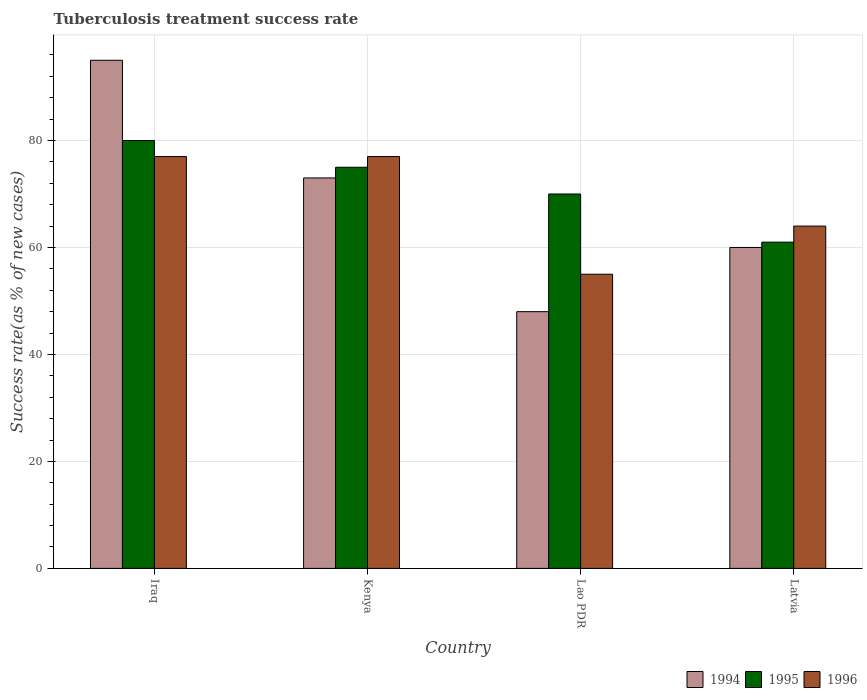How many different coloured bars are there?
Offer a terse response. 3. How many groups of bars are there?
Offer a very short reply. 4. Are the number of bars per tick equal to the number of legend labels?
Ensure brevity in your answer.  Yes. How many bars are there on the 1st tick from the left?
Offer a very short reply. 3. How many bars are there on the 1st tick from the right?
Your answer should be very brief. 3. What is the label of the 4th group of bars from the left?
Ensure brevity in your answer.  Latvia. In which country was the tuberculosis treatment success rate in 1994 maximum?
Your answer should be compact. Iraq. In which country was the tuberculosis treatment success rate in 1995 minimum?
Your answer should be compact. Latvia. What is the total tuberculosis treatment success rate in 1995 in the graph?
Ensure brevity in your answer.  286. What is the difference between the tuberculosis treatment success rate in 1994 in Kenya and the tuberculosis treatment success rate in 1996 in Lao PDR?
Your response must be concise. 18. What is the average tuberculosis treatment success rate in 1995 per country?
Keep it short and to the point. 71.5. What is the difference between the tuberculosis treatment success rate of/in 1994 and tuberculosis treatment success rate of/in 1996 in Latvia?
Make the answer very short. -4. In how many countries, is the tuberculosis treatment success rate in 1995 greater than 72 %?
Give a very brief answer. 2. What is the ratio of the tuberculosis treatment success rate in 1995 in Kenya to that in Latvia?
Your response must be concise. 1.23. What is the difference between the highest and the lowest tuberculosis treatment success rate in 1994?
Provide a short and direct response. 47. What does the 3rd bar from the left in Iraq represents?
Your answer should be compact. 1996. What does the 3rd bar from the right in Lao PDR represents?
Your answer should be very brief. 1994. How many bars are there?
Your answer should be very brief. 12. Are all the bars in the graph horizontal?
Give a very brief answer. No. What is the difference between two consecutive major ticks on the Y-axis?
Your answer should be very brief. 20. Does the graph contain any zero values?
Offer a terse response. No. Does the graph contain grids?
Your answer should be compact. Yes. How are the legend labels stacked?
Your response must be concise. Horizontal. What is the title of the graph?
Your answer should be very brief. Tuberculosis treatment success rate. Does "1968" appear as one of the legend labels in the graph?
Make the answer very short. No. What is the label or title of the X-axis?
Keep it short and to the point. Country. What is the label or title of the Y-axis?
Your answer should be very brief. Success rate(as % of new cases). What is the Success rate(as % of new cases) of 1994 in Iraq?
Your answer should be compact. 95. What is the Success rate(as % of new cases) in 1996 in Iraq?
Keep it short and to the point. 77. What is the Success rate(as % of new cases) in 1995 in Kenya?
Offer a terse response. 75. What is the Success rate(as % of new cases) of 1996 in Kenya?
Offer a terse response. 77. What is the Success rate(as % of new cases) in 1995 in Lao PDR?
Provide a succinct answer. 70. What is the Success rate(as % of new cases) of 1994 in Latvia?
Provide a succinct answer. 60. What is the Success rate(as % of new cases) in 1996 in Latvia?
Ensure brevity in your answer.  64. Across all countries, what is the maximum Success rate(as % of new cases) of 1994?
Give a very brief answer. 95. Across all countries, what is the maximum Success rate(as % of new cases) of 1995?
Provide a short and direct response. 80. Across all countries, what is the maximum Success rate(as % of new cases) of 1996?
Provide a short and direct response. 77. Across all countries, what is the minimum Success rate(as % of new cases) in 1994?
Your answer should be compact. 48. What is the total Success rate(as % of new cases) in 1994 in the graph?
Offer a terse response. 276. What is the total Success rate(as % of new cases) in 1995 in the graph?
Ensure brevity in your answer.  286. What is the total Success rate(as % of new cases) in 1996 in the graph?
Keep it short and to the point. 273. What is the difference between the Success rate(as % of new cases) in 1996 in Iraq and that in Kenya?
Offer a very short reply. 0. What is the difference between the Success rate(as % of new cases) in 1994 in Iraq and that in Lao PDR?
Provide a short and direct response. 47. What is the difference between the Success rate(as % of new cases) of 1995 in Iraq and that in Lao PDR?
Provide a short and direct response. 10. What is the difference between the Success rate(as % of new cases) of 1995 in Iraq and that in Latvia?
Your answer should be compact. 19. What is the difference between the Success rate(as % of new cases) of 1994 in Lao PDR and that in Latvia?
Your response must be concise. -12. What is the difference between the Success rate(as % of new cases) of 1996 in Lao PDR and that in Latvia?
Give a very brief answer. -9. What is the difference between the Success rate(as % of new cases) of 1994 in Iraq and the Success rate(as % of new cases) of 1996 in Kenya?
Make the answer very short. 18. What is the difference between the Success rate(as % of new cases) of 1995 in Iraq and the Success rate(as % of new cases) of 1996 in Lao PDR?
Make the answer very short. 25. What is the difference between the Success rate(as % of new cases) in 1994 in Iraq and the Success rate(as % of new cases) in 1995 in Latvia?
Make the answer very short. 34. What is the difference between the Success rate(as % of new cases) in 1994 in Iraq and the Success rate(as % of new cases) in 1996 in Latvia?
Your response must be concise. 31. What is the difference between the Success rate(as % of new cases) in 1995 in Iraq and the Success rate(as % of new cases) in 1996 in Latvia?
Keep it short and to the point. 16. What is the difference between the Success rate(as % of new cases) of 1994 in Kenya and the Success rate(as % of new cases) of 1996 in Lao PDR?
Give a very brief answer. 18. What is the difference between the Success rate(as % of new cases) in 1995 in Kenya and the Success rate(as % of new cases) in 1996 in Lao PDR?
Provide a short and direct response. 20. What is the difference between the Success rate(as % of new cases) in 1995 in Lao PDR and the Success rate(as % of new cases) in 1996 in Latvia?
Make the answer very short. 6. What is the average Success rate(as % of new cases) of 1994 per country?
Provide a succinct answer. 69. What is the average Success rate(as % of new cases) of 1995 per country?
Make the answer very short. 71.5. What is the average Success rate(as % of new cases) of 1996 per country?
Make the answer very short. 68.25. What is the difference between the Success rate(as % of new cases) in 1994 and Success rate(as % of new cases) in 1995 in Iraq?
Provide a succinct answer. 15. What is the difference between the Success rate(as % of new cases) in 1994 and Success rate(as % of new cases) in 1995 in Kenya?
Provide a succinct answer. -2. What is the difference between the Success rate(as % of new cases) of 1994 and Success rate(as % of new cases) of 1996 in Kenya?
Make the answer very short. -4. What is the difference between the Success rate(as % of new cases) in 1994 and Success rate(as % of new cases) in 1996 in Latvia?
Your answer should be very brief. -4. What is the difference between the Success rate(as % of new cases) in 1995 and Success rate(as % of new cases) in 1996 in Latvia?
Keep it short and to the point. -3. What is the ratio of the Success rate(as % of new cases) of 1994 in Iraq to that in Kenya?
Make the answer very short. 1.3. What is the ratio of the Success rate(as % of new cases) in 1995 in Iraq to that in Kenya?
Ensure brevity in your answer.  1.07. What is the ratio of the Success rate(as % of new cases) of 1996 in Iraq to that in Kenya?
Offer a very short reply. 1. What is the ratio of the Success rate(as % of new cases) of 1994 in Iraq to that in Lao PDR?
Offer a very short reply. 1.98. What is the ratio of the Success rate(as % of new cases) of 1996 in Iraq to that in Lao PDR?
Ensure brevity in your answer.  1.4. What is the ratio of the Success rate(as % of new cases) in 1994 in Iraq to that in Latvia?
Offer a terse response. 1.58. What is the ratio of the Success rate(as % of new cases) of 1995 in Iraq to that in Latvia?
Your answer should be compact. 1.31. What is the ratio of the Success rate(as % of new cases) in 1996 in Iraq to that in Latvia?
Give a very brief answer. 1.2. What is the ratio of the Success rate(as % of new cases) of 1994 in Kenya to that in Lao PDR?
Your answer should be compact. 1.52. What is the ratio of the Success rate(as % of new cases) in 1995 in Kenya to that in Lao PDR?
Offer a very short reply. 1.07. What is the ratio of the Success rate(as % of new cases) of 1996 in Kenya to that in Lao PDR?
Offer a terse response. 1.4. What is the ratio of the Success rate(as % of new cases) of 1994 in Kenya to that in Latvia?
Offer a very short reply. 1.22. What is the ratio of the Success rate(as % of new cases) in 1995 in Kenya to that in Latvia?
Ensure brevity in your answer.  1.23. What is the ratio of the Success rate(as % of new cases) in 1996 in Kenya to that in Latvia?
Make the answer very short. 1.2. What is the ratio of the Success rate(as % of new cases) in 1995 in Lao PDR to that in Latvia?
Make the answer very short. 1.15. What is the ratio of the Success rate(as % of new cases) in 1996 in Lao PDR to that in Latvia?
Your answer should be compact. 0.86. What is the difference between the highest and the second highest Success rate(as % of new cases) in 1994?
Provide a short and direct response. 22. What is the difference between the highest and the second highest Success rate(as % of new cases) in 1996?
Your answer should be very brief. 0. What is the difference between the highest and the lowest Success rate(as % of new cases) of 1994?
Your response must be concise. 47. What is the difference between the highest and the lowest Success rate(as % of new cases) of 1996?
Your response must be concise. 22. 